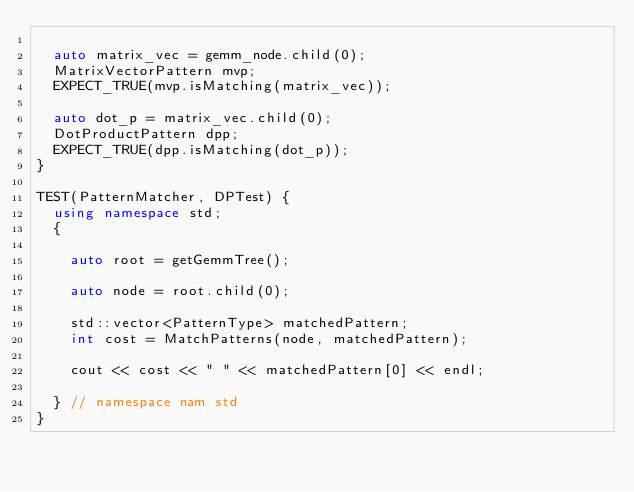Convert code to text. <code><loc_0><loc_0><loc_500><loc_500><_C++_>
  auto matrix_vec = gemm_node.child(0);
  MatrixVectorPattern mvp;
  EXPECT_TRUE(mvp.isMatching(matrix_vec));

  auto dot_p = matrix_vec.child(0);
  DotProductPattern dpp;
  EXPECT_TRUE(dpp.isMatching(dot_p));
}

TEST(PatternMatcher, DPTest) {
  using namespace std;
  {

    auto root = getGemmTree();

    auto node = root.child(0);

    std::vector<PatternType> matchedPattern;
    int cost = MatchPatterns(node, matchedPattern);

    cout << cost << " " << matchedPattern[0] << endl;

  } // namespace nam std
}</code> 